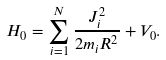<formula> <loc_0><loc_0><loc_500><loc_500>H _ { 0 } = \sum _ { i = 1 } ^ { N } \frac { J _ { i } ^ { 2 } } { 2 m _ { i } R ^ { 2 } } + V _ { 0 } .</formula> 